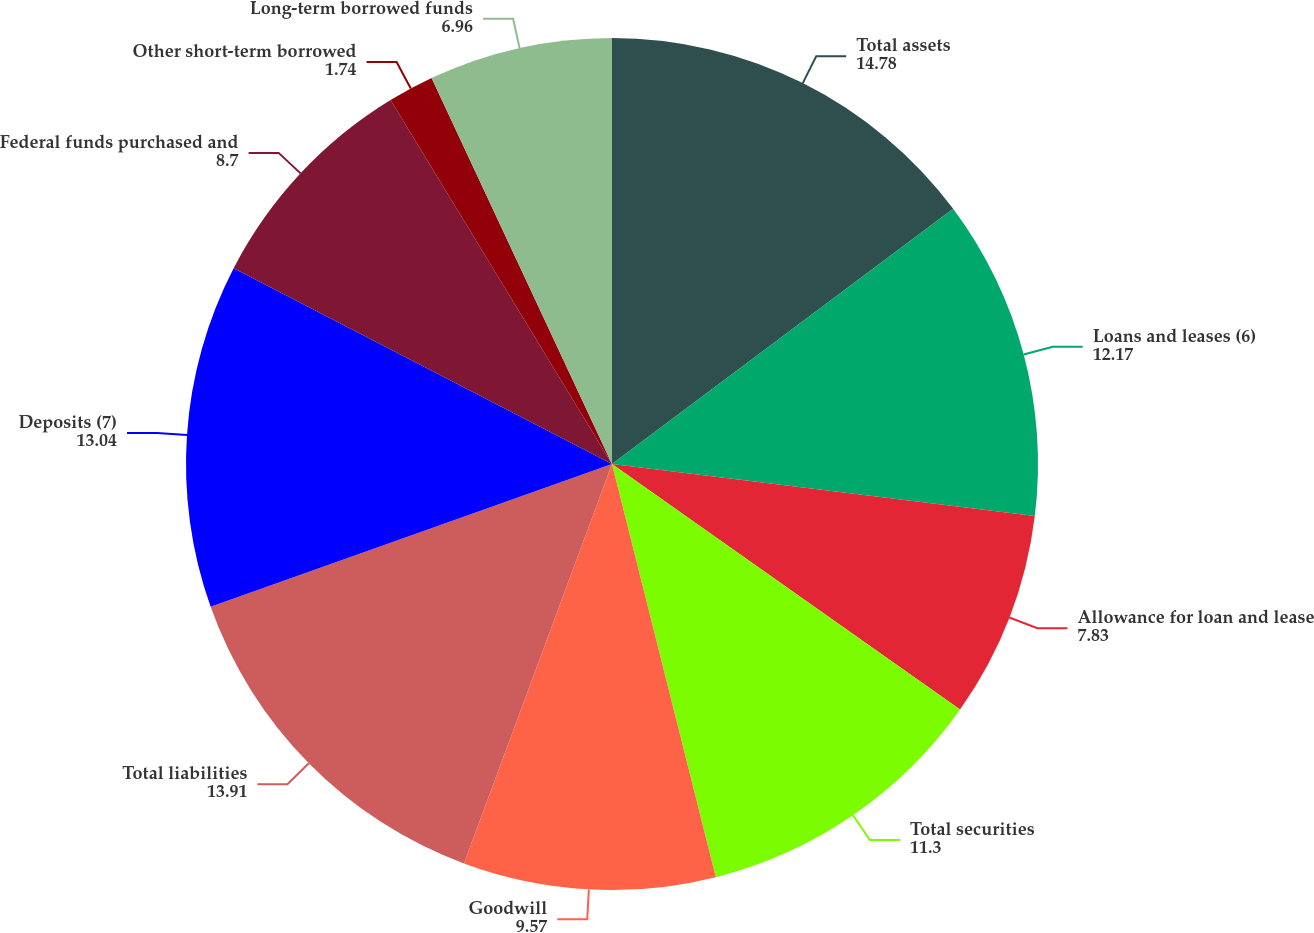Convert chart. <chart><loc_0><loc_0><loc_500><loc_500><pie_chart><fcel>Total assets<fcel>Loans and leases (6)<fcel>Allowance for loan and lease<fcel>Total securities<fcel>Goodwill<fcel>Total liabilities<fcel>Deposits (7)<fcel>Federal funds purchased and<fcel>Other short-term borrowed<fcel>Long-term borrowed funds<nl><fcel>14.78%<fcel>12.17%<fcel>7.83%<fcel>11.3%<fcel>9.57%<fcel>13.91%<fcel>13.04%<fcel>8.7%<fcel>1.74%<fcel>6.96%<nl></chart> 